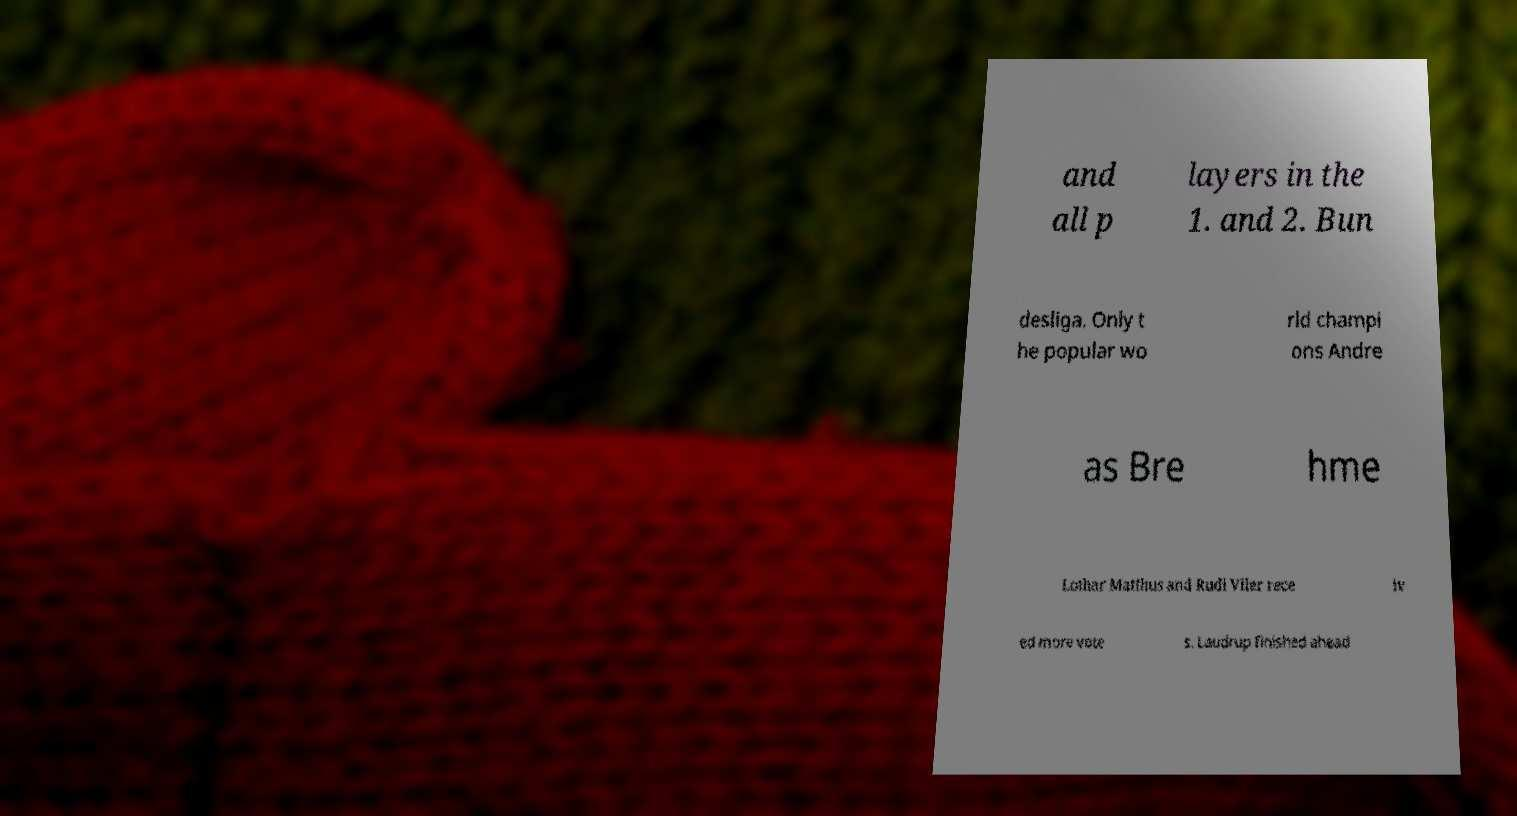What messages or text are displayed in this image? I need them in a readable, typed format. and all p layers in the 1. and 2. Bun desliga. Only t he popular wo rld champi ons Andre as Bre hme Lothar Matthus and Rudi Vller rece iv ed more vote s. Laudrup finished ahead 